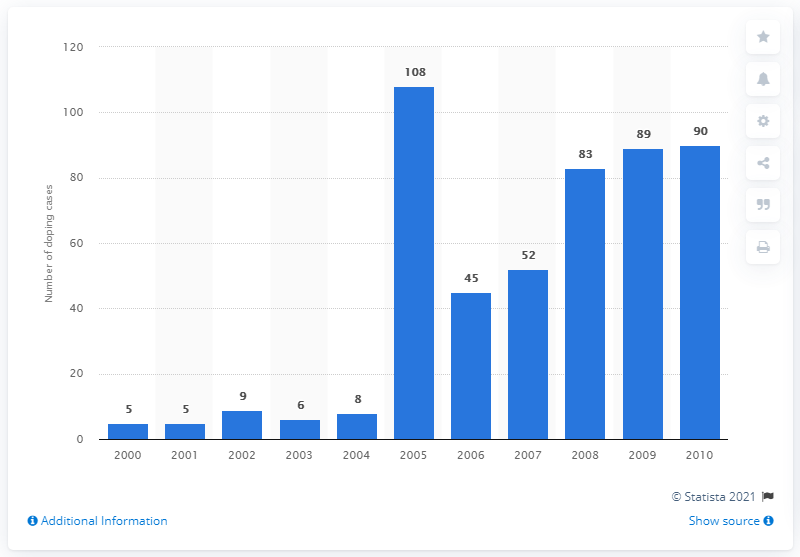Highlight a few significant elements in this photo. In 2000, there were 5 cases of doping. 